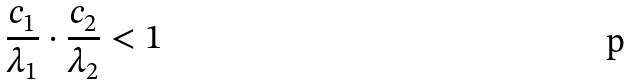<formula> <loc_0><loc_0><loc_500><loc_500>\frac { c _ { 1 } } { \lambda _ { 1 } } \cdot \frac { c _ { 2 } } { \lambda _ { 2 } } < 1</formula> 